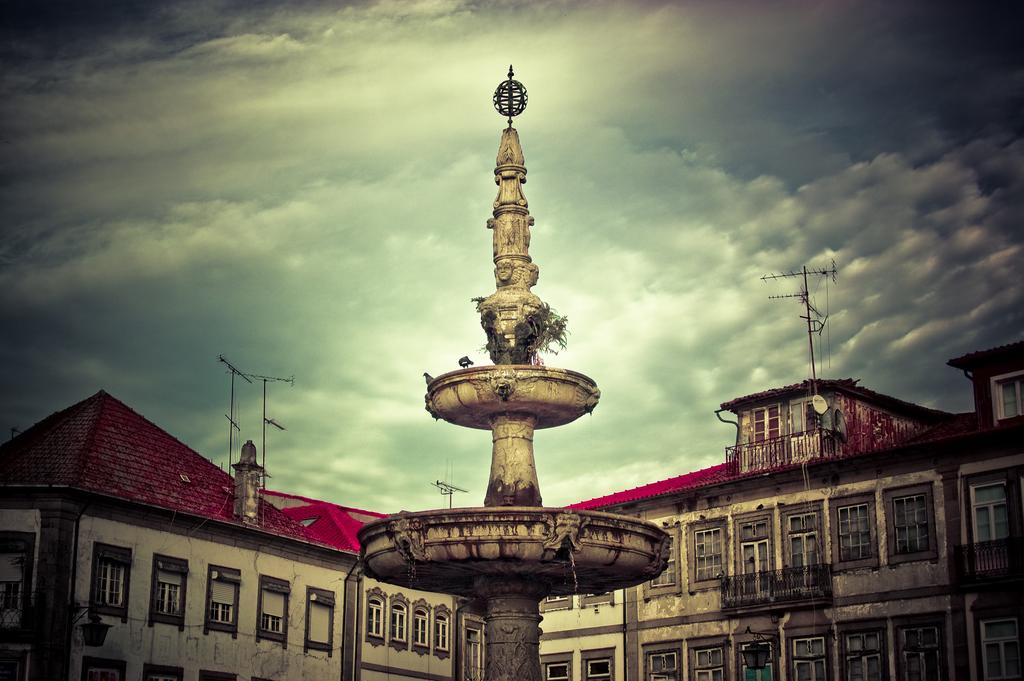What type of structure is featured in the image? There is a sculpture water fountain in the image. What other type of structure can be seen in the image? There is a building in the image. What can be seen in the background of the image? The sky is visible in the background of the image. How does the boy react to the shock of the sculpture water fountain in the image? There is no boy or shock present in the image; it features a sculpture water fountain and a building. 